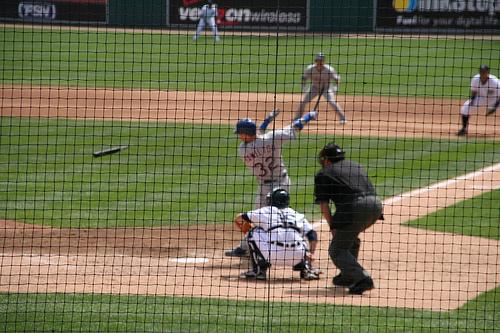Provide a brief description that conveys the primary elements in the image. A baseball game scene with multiple players wearing baseball uniforms, a cat on a television, and baseball equipment on the grass. In a casual manner, describe any peculiar detail present in the image. Lol, there's a cat just standing on a TV amidst all this baseball action! Using slang or colloquial language, describe an unexpected detail in the image. Gotta say, it's pretty whack seeing a random cat chilling on top of a TV in this baseball pic. What are three components of the baseball field environment in the image? 3. Advertisement billboards on the wall Mention three objects and their respective positions in the image. A baseball bat is in the grass, a blue baseball hat is on a player's head, and a black helmet is worn by a catcher. Give a concise description of what the baseball catcher and umpire are wearing. The catcher is wearing a black mask and a white shirt while the umpire has a black mask and black shirt on. Describe two accessories seen on the baseball players in the image. A player sports a blue helmet and another player has a number on the back of their jersey. With a touch of humor, mention something peculiar about the image. Well, this has got to be the first time I've seen a baseball game and a cheeky cat on a TV sharing the same frame! Write a one-sentence summary of the image's overall content. This image features a baseball game with players in action, baseball equipment on the field, and a cat standing on a television. Enumerate three clothing items worn by the baseball players in the image. 3. Black and grey shirt 